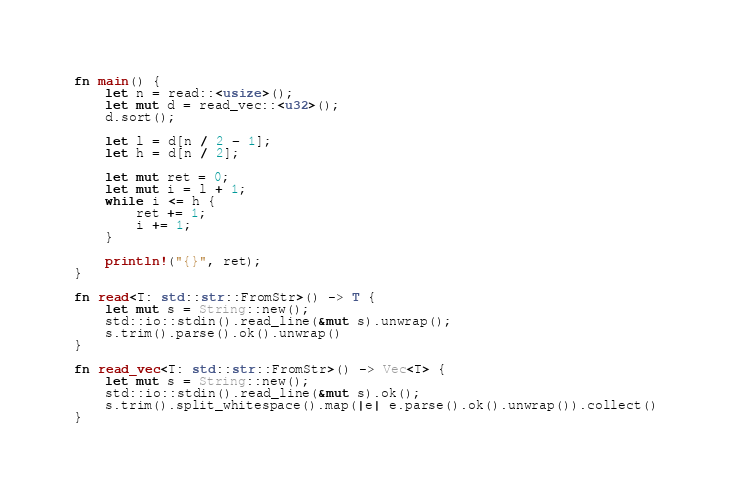<code> <loc_0><loc_0><loc_500><loc_500><_Rust_>fn main() {
    let n = read::<usize>();
    let mut d = read_vec::<u32>();
    d.sort();

    let l = d[n / 2 - 1];
    let h = d[n / 2];

    let mut ret = 0;
    let mut i = l + 1;
    while i <= h {
        ret += 1;
        i += 1;
    }

    println!("{}", ret);
}

fn read<T: std::str::FromStr>() -> T {
    let mut s = String::new();
    std::io::stdin().read_line(&mut s).unwrap();
    s.trim().parse().ok().unwrap()
}

fn read_vec<T: std::str::FromStr>() -> Vec<T> {
    let mut s = String::new();
    std::io::stdin().read_line(&mut s).ok();
    s.trim().split_whitespace().map(|e| e.parse().ok().unwrap()).collect()
}</code> 